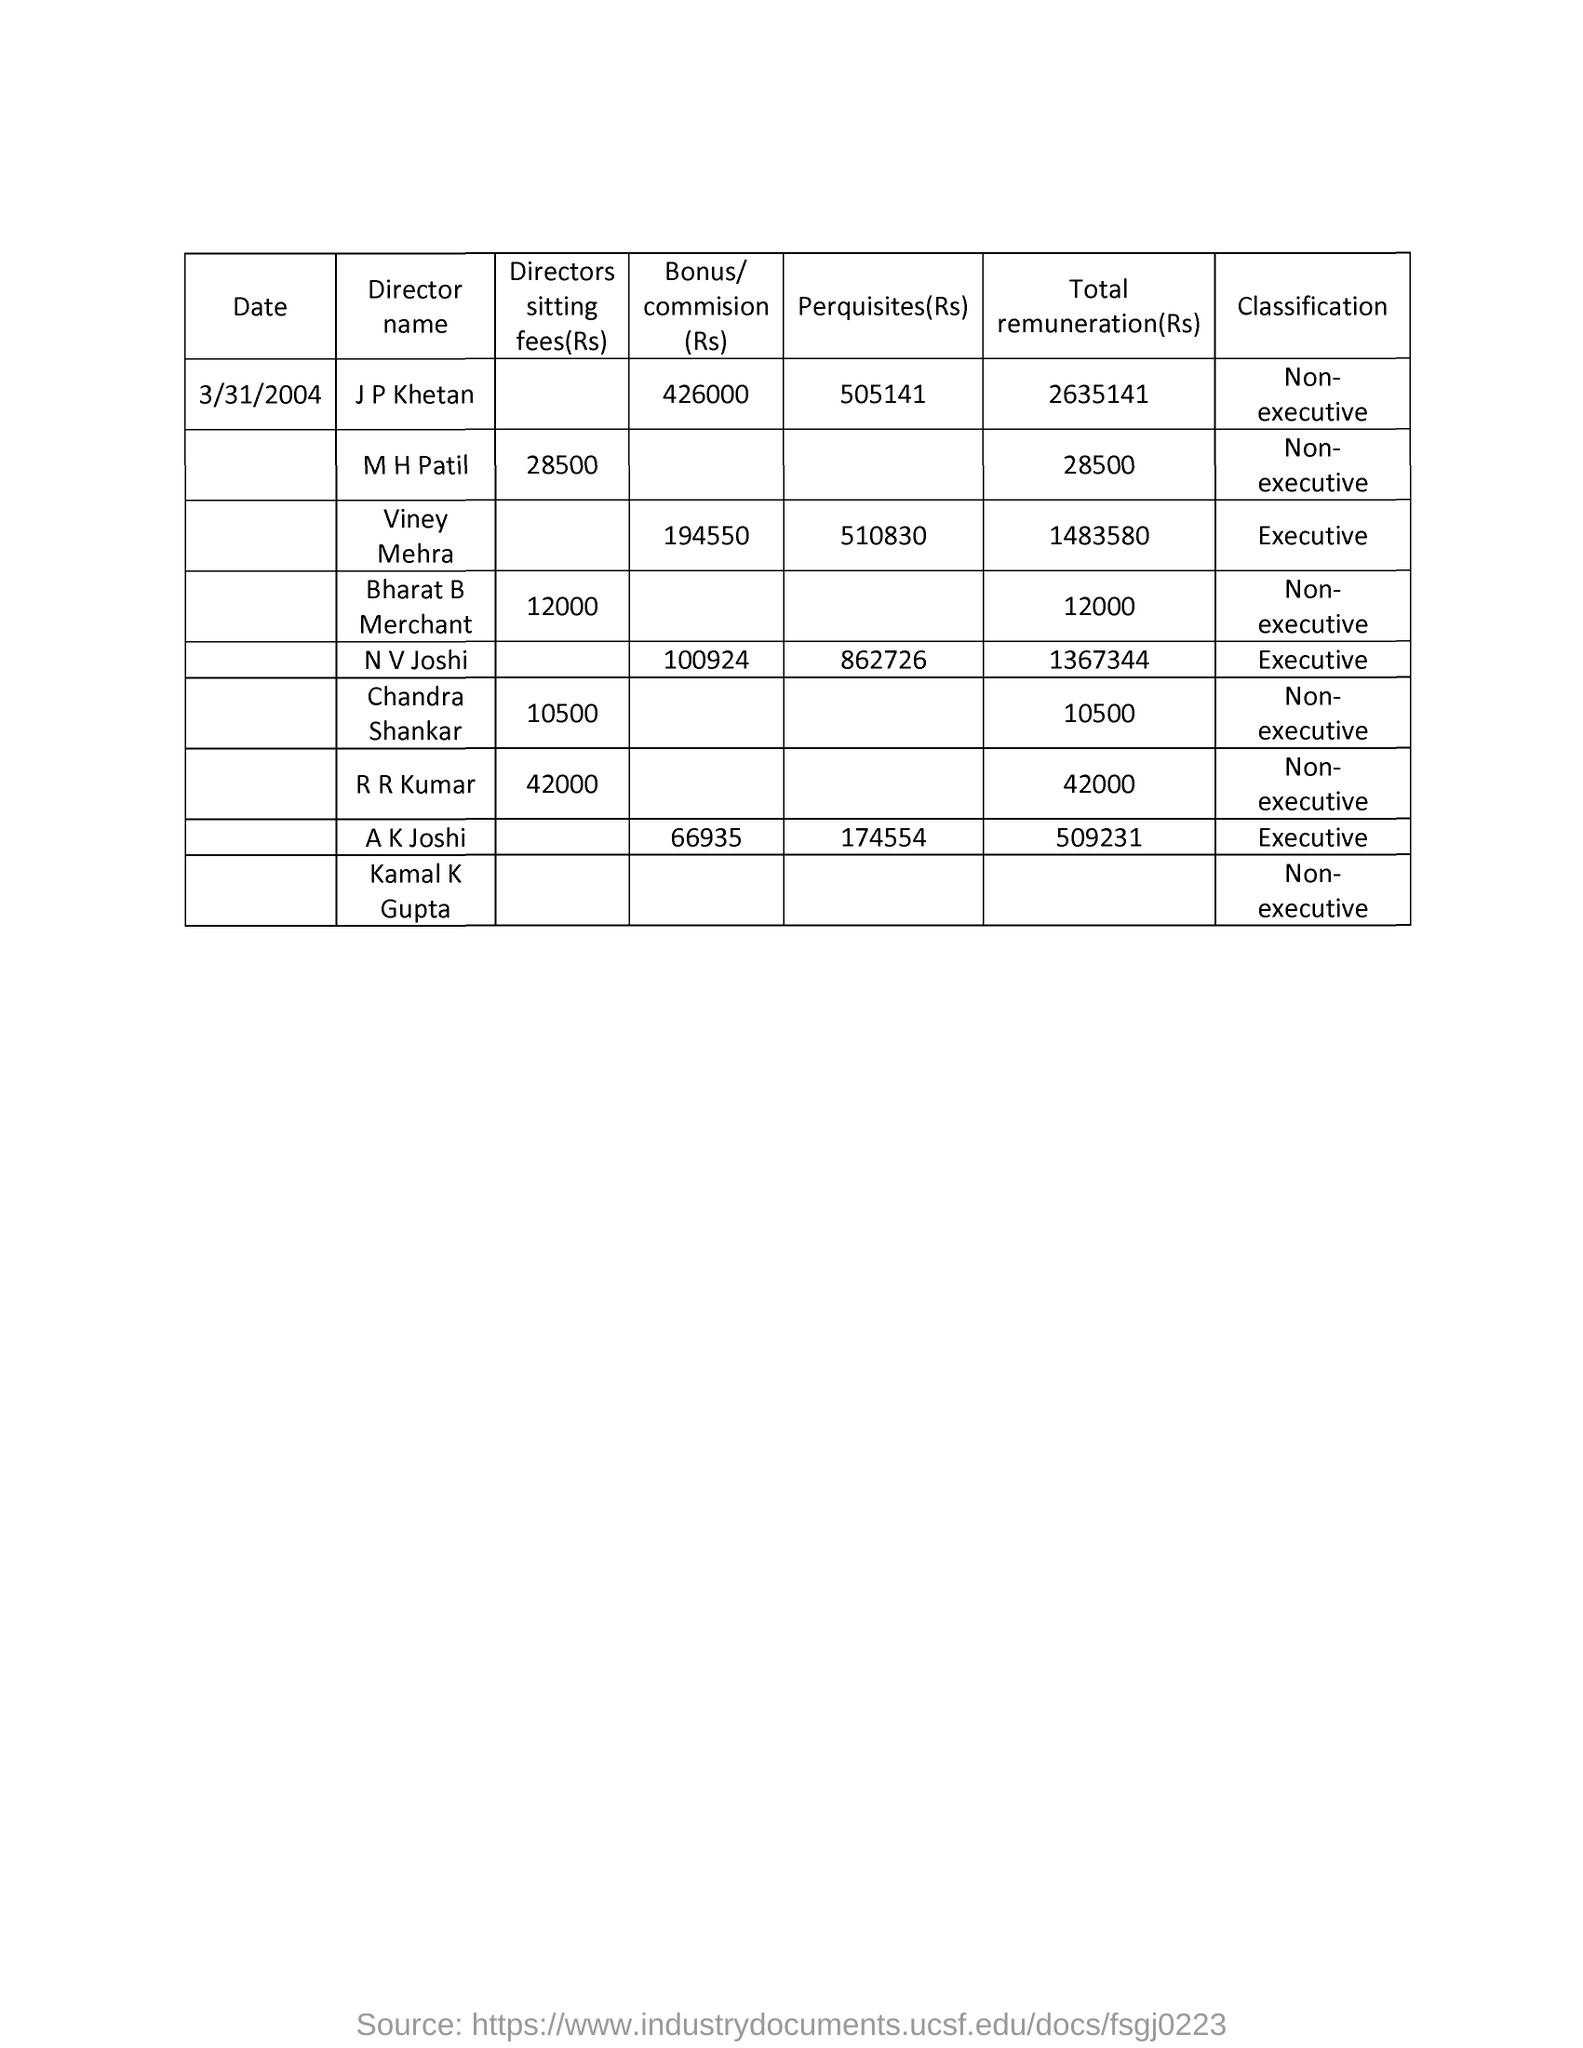Specify some key components in this picture. The director fee of R. R. Kumar is 42,000. The date mentioned in the document is 3/31/2004. The total remuneration of Bharat B Merchant is 12,000. The name of the director whose perquisites are 50,514.1 is J P Khetan. 